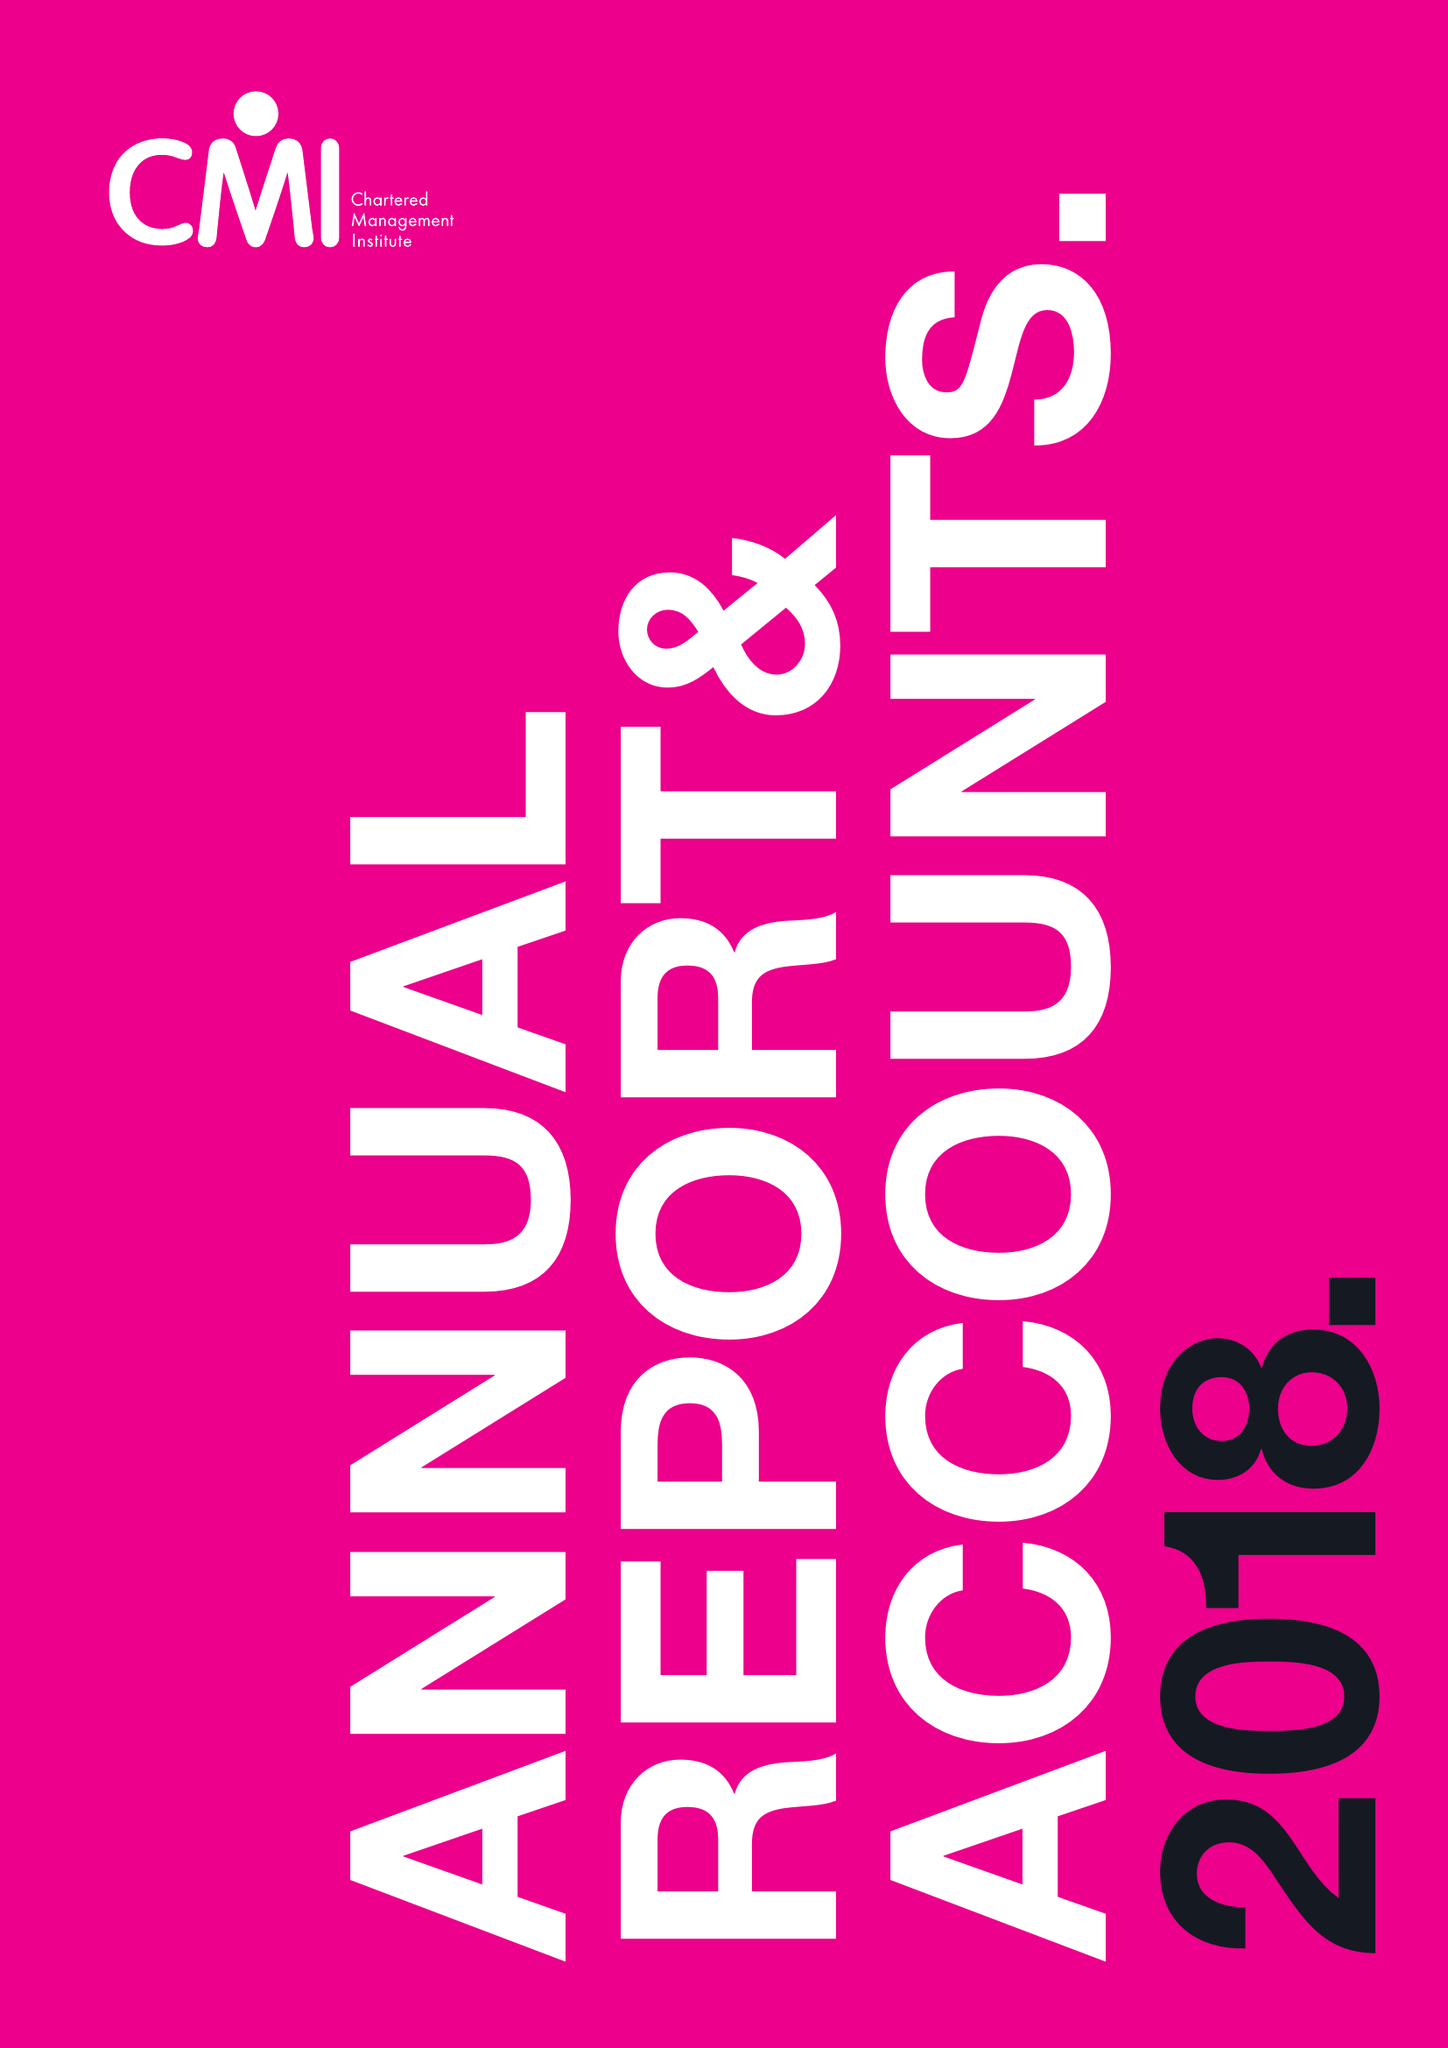What is the value for the address__street_line?
Answer the question using a single word or phrase. COTTINGHAM ROAD 